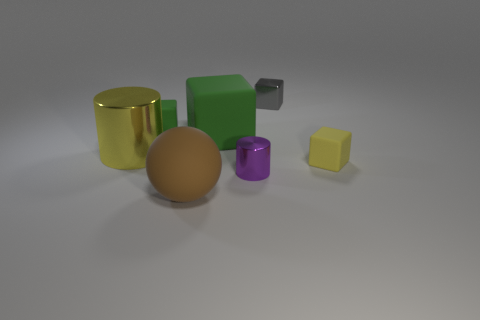How many tiny green cubes are made of the same material as the brown object?
Keep it short and to the point. 1. How many metallic things are either brown things or tiny red blocks?
Your answer should be very brief. 0. There is a green block that is the same size as the gray metal cube; what material is it?
Make the answer very short. Rubber. Are there any other objects that have the same material as the tiny purple thing?
Offer a very short reply. Yes. There is a yellow thing that is to the left of the thing in front of the small metal thing that is in front of the small gray shiny thing; what shape is it?
Keep it short and to the point. Cylinder. Is the size of the yellow block the same as the yellow object on the left side of the yellow block?
Your answer should be compact. No. What shape is the object that is in front of the yellow matte cube and on the left side of the large green thing?
Make the answer very short. Sphere. How many big things are either shiny blocks or purple objects?
Offer a very short reply. 0. Is the number of tiny cylinders in front of the purple shiny thing the same as the number of large matte cubes that are behind the yellow cylinder?
Keep it short and to the point. No. How many other things are the same color as the big metallic thing?
Provide a short and direct response. 1. 